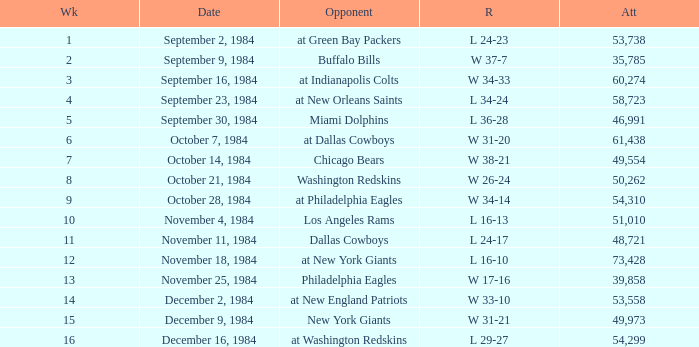Who was the opponent on October 14, 1984? Chicago Bears. 